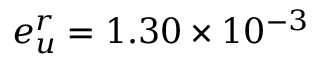Convert formula to latex. <formula><loc_0><loc_0><loc_500><loc_500>e _ { u } ^ { r } = 1 . 3 0 \times 1 0 ^ { - 3 }</formula> 